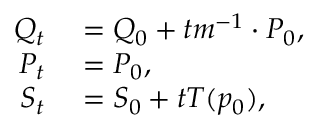Convert formula to latex. <formula><loc_0><loc_0><loc_500><loc_500>\begin{array} { r l } { Q _ { t } } & = Q _ { 0 } + t m ^ { - 1 } \cdot P _ { 0 } , } \\ { P _ { t } } & = P _ { 0 } , } \\ { S _ { t } } & = S _ { 0 } + t T ( p _ { 0 } ) , } \end{array}</formula> 